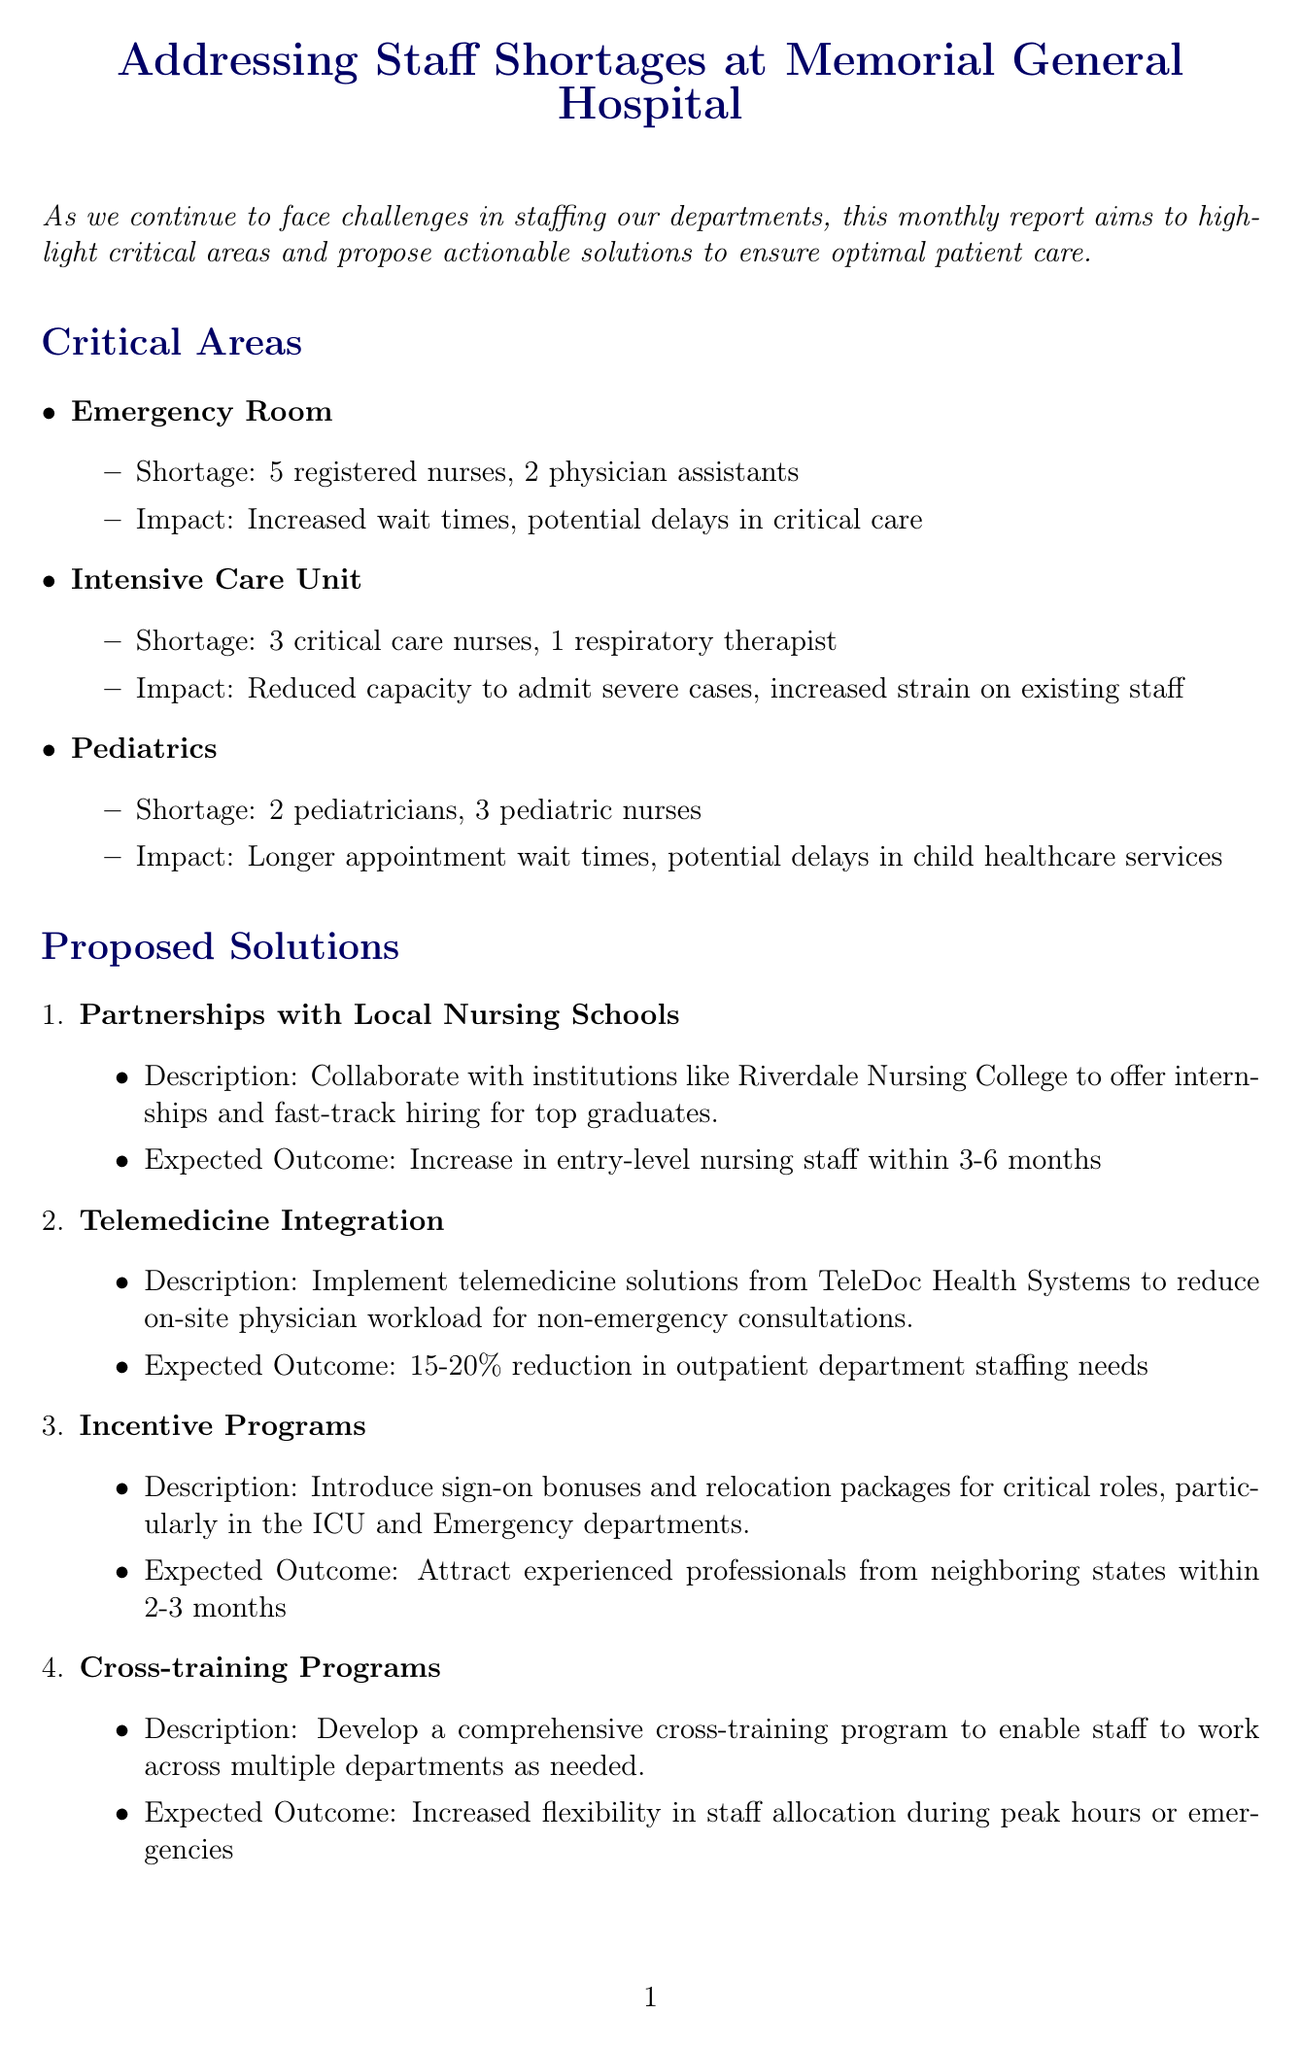What is the title of the newsletter? The title is stated at the beginning of the document as "Addressing Staff Shortages at Memorial General Hospital."
Answer: Addressing Staff Shortages at Memorial General Hospital How many registered nurses are missing in the Emergency Room? The document specifies that there is a shortage of 5 registered nurses in the Emergency Room.
Answer: 5 registered nurses What strategy involves collaborating with local nursing schools? The document describes a strategy that involves offering internships and fast-track hiring for top graduates from local nursing schools.
Answer: Partnerships with Local Nursing Schools What is the expected outcome of implementing telemedicine solutions? The document states that telemedicine integration is expected to lead to a 15-20% reduction in outpatient department staffing needs.
Answer: 15-20% reduction What is the date and time of the upcoming town hall meeting? The call to action in the document mentions the town hall meeting is scheduled for July 15th at 3 PM.
Answer: July 15th at 3 PM How many pediatric nurses are in shortage in the Pediatrics department? The document indicates there is a shortage of 3 pediatric nurses in the Pediatrics department.
Answer: 3 pediatric nurses 